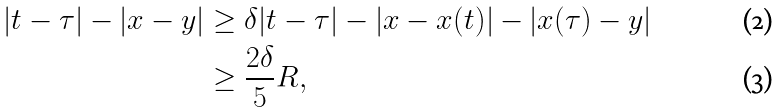Convert formula to latex. <formula><loc_0><loc_0><loc_500><loc_500>| t - \tau | - | x - y | & \geq \delta | t - \tau | - | x - x ( t ) | - | x ( \tau ) - y | \\ & \geq \frac { 2 \delta } { 5 } R ,</formula> 